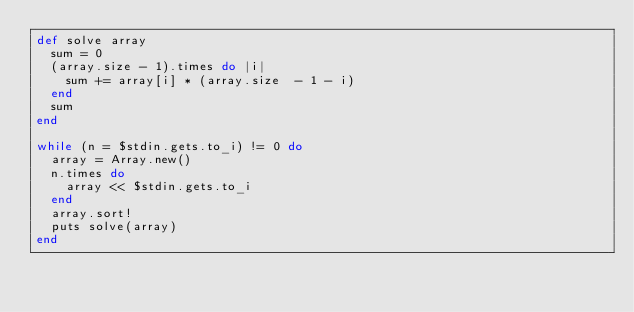Convert code to text. <code><loc_0><loc_0><loc_500><loc_500><_Ruby_>def solve array
  sum = 0
  (array.size - 1).times do |i|
    sum += array[i] * (array.size  - 1 - i)
  end
  sum
end

while (n = $stdin.gets.to_i) != 0 do
  array = Array.new()
  n.times do
    array << $stdin.gets.to_i
  end
  array.sort!
  puts solve(array)
end</code> 